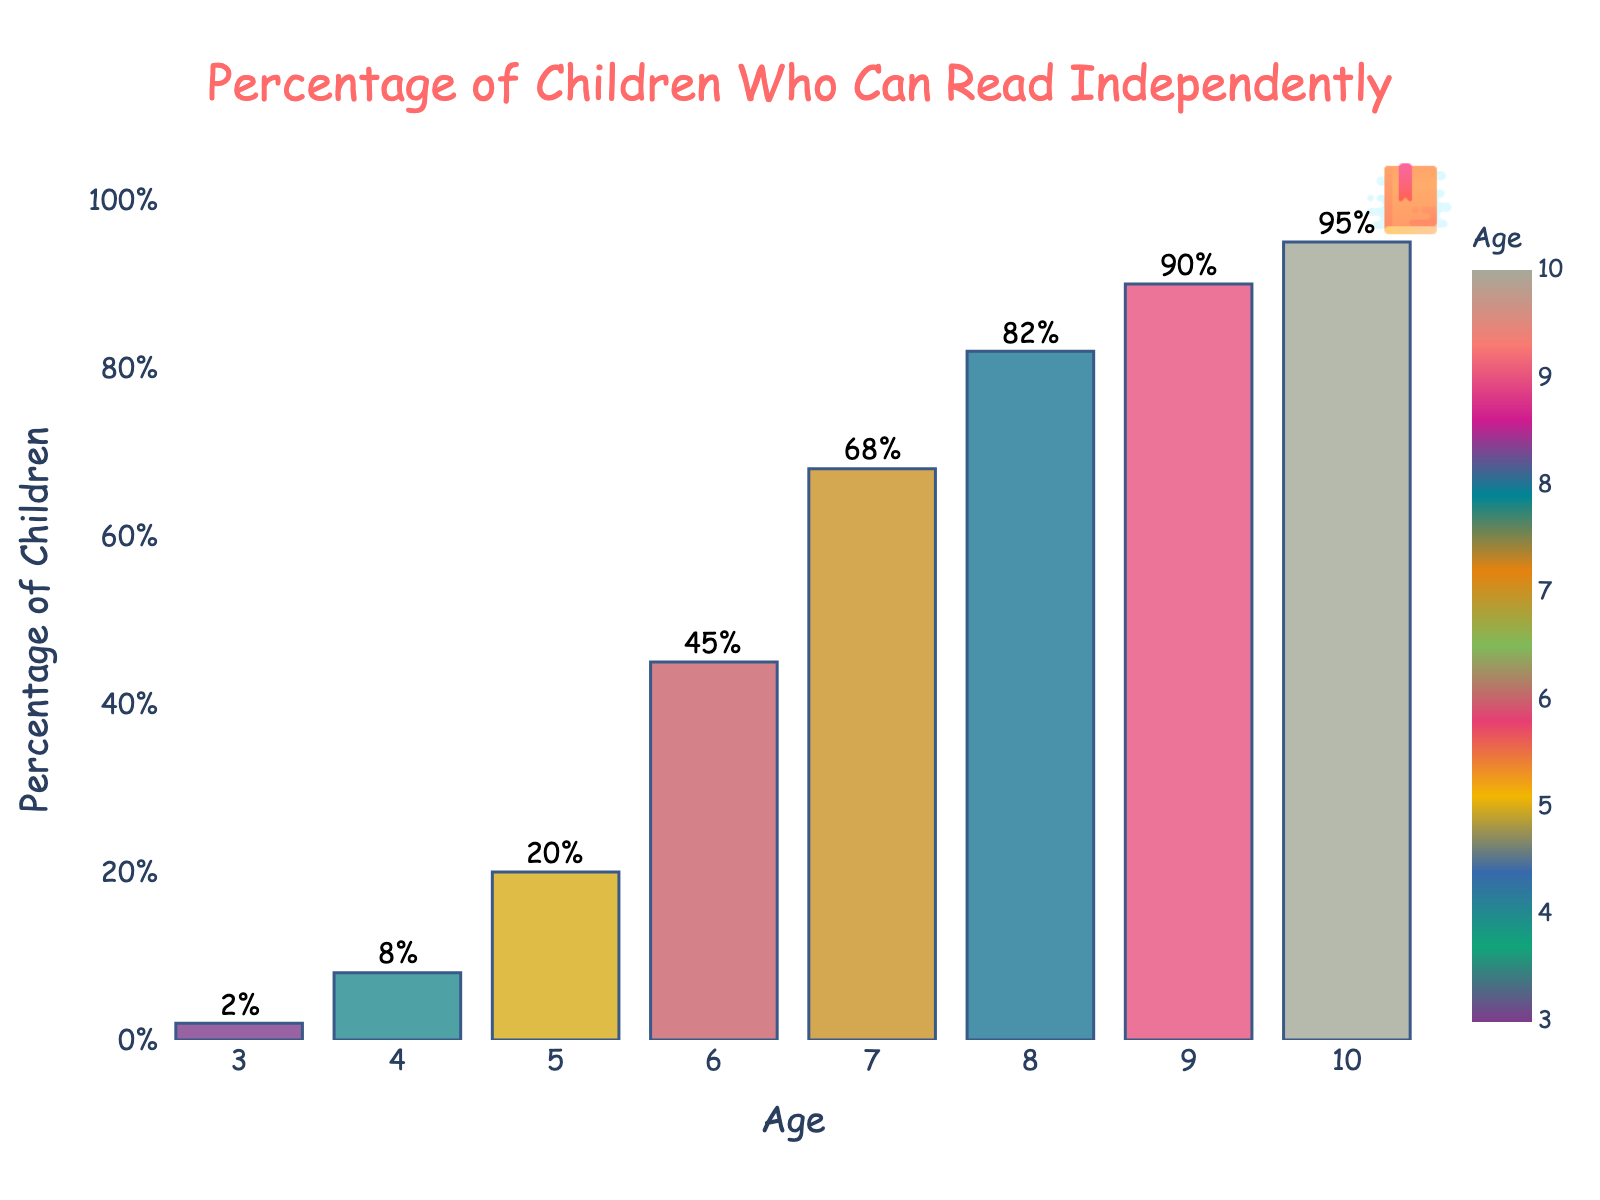What is the percentage of 5-year-old children who can read independently? According to the bar chart, for age 5, the percentage is represented by the height of the corresponding bar. The annotation on the bar shows 20%.
Answer: 20% How much higher is the percentage of children who can read at age 10 compared to age 7? The percentage of children who can read at age 10 is 95%, and at age 7, it is 68%. The difference is 95% - 68% = 27%.
Answer: 27% Which two age groups have the smallest difference in the percentage of children who can read independently? By examining the consecutive bars and their annotations, ages 9 and 10 have the percentages of 90% and 95%, respectively. The difference is 95% - 90% = 5%, which is the smallest difference between consecutive ages.
Answer: Ages 9 and 10 At what age do more than half of the children start reading independently? The bar chart shows that at age 6, the percentage is 45%, and at age 7, it leaps to 68%. Thus, more than half of the children start reading independently at age 7.
Answer: Age 7 What is the average percentage of children who can read independently at ages 3, 4, and 5? The percentages for ages 3, 4, and 5 are 2%, 8%, and 20%, respectively. Calculating the average: (2 + 8 + 20) / 3 = 30 / 3 = 10%.
Answer: 10% Which age group has the steepest increase in the percentage of children who can read independently compared to the previous age? To determine the steepest increase, examine the differences between consecutive age groups. The greatest difference is between ages 5 (20%) and 6 (45%), which is 45% - 20% = 25%.
Answer: Ages 5 and 6 What percentage of 4-year-old children can read independently compared to 8-year-old children? The bar chart indicates that 4-year-olds have an 8% reading rate, while 8-year-olds have an 82% rate. Therefore, 4-year-olds read at 8% out of 82%, which is approximately 9.76%.
Answer: ~9.76% How many times higher is the percentage of 10-year-old children who can read independently compared to 3-year-old children? The percentage for 3-year-olds is 2% and for 10-year-olds is 95%. Calculating how many times higher: 95 / 2 = 47.5 times higher.
Answer: 47.5 times 